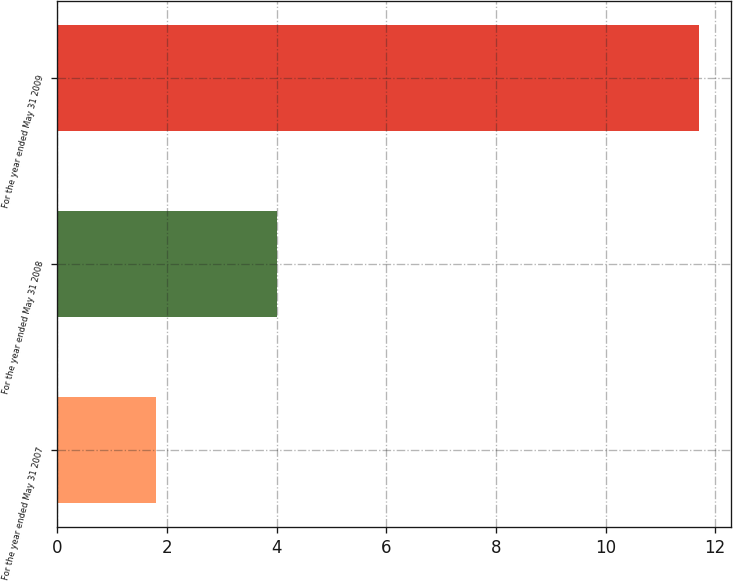Convert chart. <chart><loc_0><loc_0><loc_500><loc_500><bar_chart><fcel>For the year ended May 31 2007<fcel>For the year ended May 31 2008<fcel>For the year ended May 31 2009<nl><fcel>1.8<fcel>4<fcel>11.7<nl></chart> 